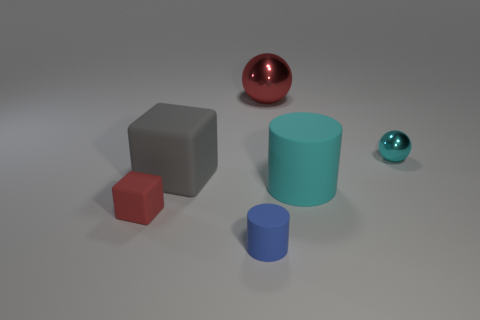Subtract 1 cylinders. How many cylinders are left? 1 Add 1 big blue shiny objects. How many objects exist? 7 Subtract all red blocks. How many blocks are left? 1 Subtract all small yellow metallic cubes. Subtract all tiny blue things. How many objects are left? 5 Add 6 large metal spheres. How many large metal spheres are left? 7 Add 4 red matte blocks. How many red matte blocks exist? 5 Subtract 0 gray cylinders. How many objects are left? 6 Subtract all spheres. How many objects are left? 4 Subtract all yellow cylinders. Subtract all brown balls. How many cylinders are left? 2 Subtract all brown cubes. How many yellow cylinders are left? 0 